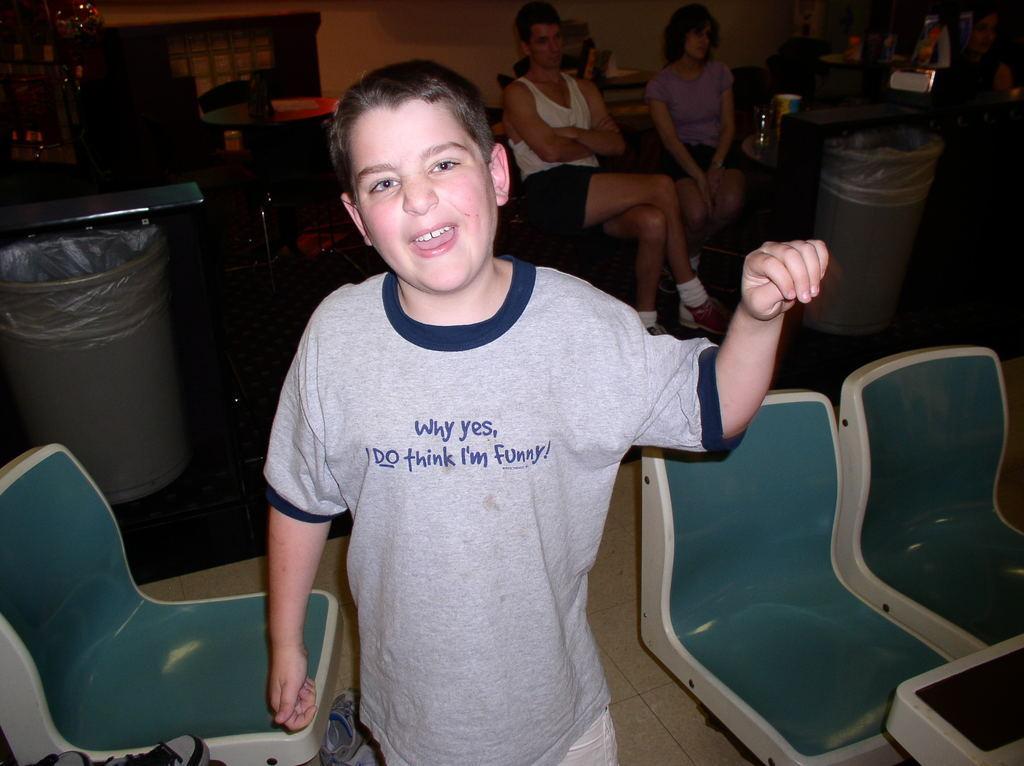Describe this image in one or two sentences. In this picture we can see boy standing and smiling and in front and beside to him we can see chairs and at back of him we can see bin, two woman sitting and wooden table, wall. 